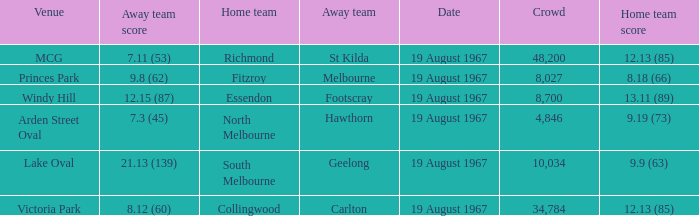What did the home team of essendon score? 13.11 (89). Write the full table. {'header': ['Venue', 'Away team score', 'Home team', 'Away team', 'Date', 'Crowd', 'Home team score'], 'rows': [['MCG', '7.11 (53)', 'Richmond', 'St Kilda', '19 August 1967', '48,200', '12.13 (85)'], ['Princes Park', '9.8 (62)', 'Fitzroy', 'Melbourne', '19 August 1967', '8,027', '8.18 (66)'], ['Windy Hill', '12.15 (87)', 'Essendon', 'Footscray', '19 August 1967', '8,700', '13.11 (89)'], ['Arden Street Oval', '7.3 (45)', 'North Melbourne', 'Hawthorn', '19 August 1967', '4,846', '9.19 (73)'], ['Lake Oval', '21.13 (139)', 'South Melbourne', 'Geelong', '19 August 1967', '10,034', '9.9 (63)'], ['Victoria Park', '8.12 (60)', 'Collingwood', 'Carlton', '19 August 1967', '34,784', '12.13 (85)']]} 